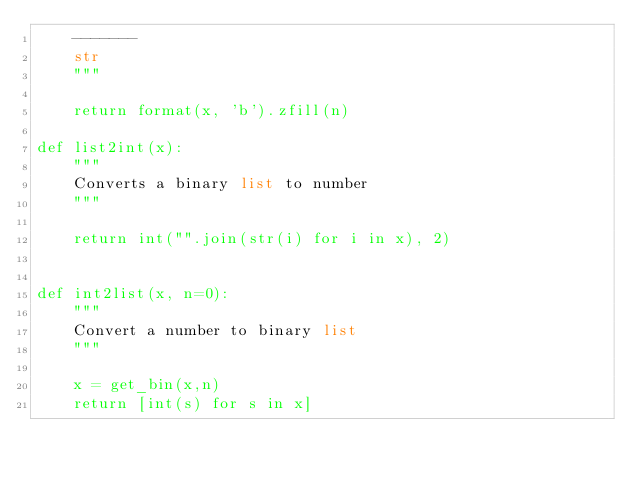Convert code to text. <code><loc_0><loc_0><loc_500><loc_500><_Python_>    -------
    str
    """

    return format(x, 'b').zfill(n)

def list2int(x):
    """
    Converts a binary list to number
    """

    return int("".join(str(i) for i in x), 2)


def int2list(x, n=0):
    """
    Convert a number to binary list
    """

    x = get_bin(x,n)
    return [int(s) for s in x]
</code> 